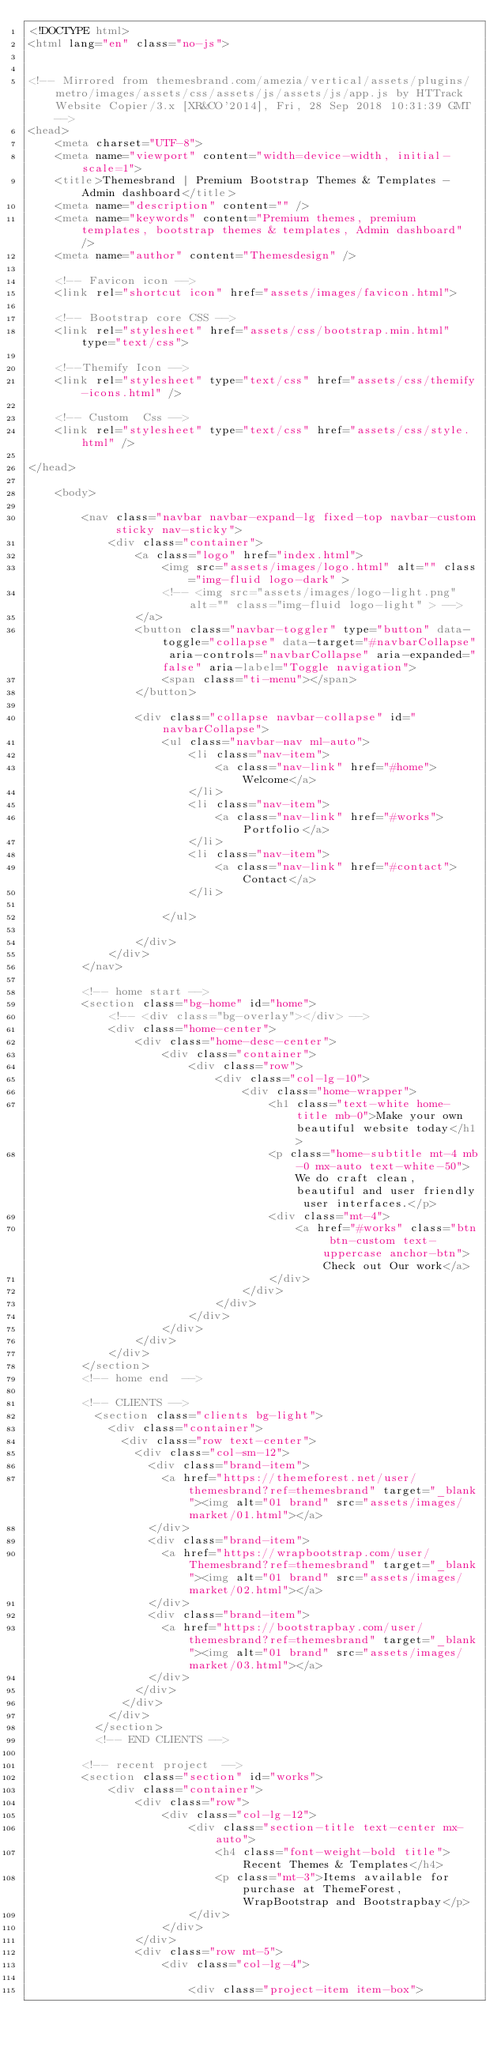Convert code to text. <code><loc_0><loc_0><loc_500><loc_500><_HTML_><!DOCTYPE html>
<html lang="en" class="no-js">


<!-- Mirrored from themesbrand.com/amezia/vertical/assets/plugins/metro/images/assets/css/assets/js/assets/js/app.js by HTTrack Website Copier/3.x [XR&CO'2014], Fri, 28 Sep 2018 10:31:39 GMT -->
<head>
    <meta charset="UTF-8">
    <meta name="viewport" content="width=device-width, initial-scale=1">
    <title>Themesbrand | Premium Bootstrap Themes & Templates - Admin dashboard</title>
    <meta name="description" content="" />
    <meta name="keywords" content="Premium themes, premium templates, bootstrap themes & templates, Admin dashboard" />
    <meta name="author" content="Themesdesign" />

    <!-- Favicon icon -->
    <link rel="shortcut icon" href="assets/images/favicon.html">

    <!-- Bootstrap core CSS -->
    <link rel="stylesheet" href="assets/css/bootstrap.min.html" type="text/css">

    <!--Themify Icon -->
    <link rel="stylesheet" type="text/css" href="assets/css/themify-icons.html" />

    <!-- Custom  Css -->
    <link rel="stylesheet" type="text/css" href="assets/css/style.html" />

</head>

    <body>

        <nav class="navbar navbar-expand-lg fixed-top navbar-custom sticky nav-sticky">
            <div class="container">
                <a class="logo" href="index.html">
                    <img src="assets/images/logo.html" alt="" class="img-fluid logo-dark" >
                    <!-- <img src="assets/images/logo-light.png" alt="" class="img-fluid logo-light" > -->
                </a>
                <button class="navbar-toggler" type="button" data-toggle="collapse" data-target="#navbarCollapse" aria-controls="navbarCollapse" aria-expanded="false" aria-label="Toggle navigation">
                    <span class="ti-menu"></span>
                </button>

                <div class="collapse navbar-collapse" id="navbarCollapse">
                    <ul class="navbar-nav ml-auto">
                        <li class="nav-item">
                            <a class="nav-link" href="#home">Welcome</a>
                        </li>
                        <li class="nav-item">
                            <a class="nav-link" href="#works">Portfolio</a>
                        </li>
                        <li class="nav-item">
                            <a class="nav-link" href="#contact">Contact</a>
                        </li>

                    </ul>

                </div>
            </div>
        </nav>

        <!-- home start -->
        <section class="bg-home" id="home">
            <!-- <div class="bg-overlay"></div> -->
            <div class="home-center">
                <div class="home-desc-center">
                    <div class="container">
                        <div class="row">
                            <div class="col-lg-10">
                                <div class="home-wrapper">
                                    <h1 class="text-white home-title mb-0">Make your own beautiful website today</h1>
                                    <p class="home-subtitle mt-4 mb-0 mx-auto text-white-50">We do craft clean, beautiful and user friendly user interfaces.</p>
                                    <div class="mt-4">
                                        <a href="#works" class="btn btn-custom text-uppercase anchor-btn">Check out Our work</a>
                                    </div>
                                </div>
                            </div>
                        </div>
                    </div>
                </div>
            </div>
        </section>
        <!-- home end  -->

        <!-- CLIENTS -->
          <section class="clients bg-light">
            <div class="container">
              <div class="row text-center">
                <div class="col-sm-12">
                  <div class="brand-item">
                    <a href="https://themeforest.net/user/themesbrand?ref=themesbrand" target="_blank"><img alt="01 brand" src="assets/images/market/01.html"></a>
                  </div>
                  <div class="brand-item">
                    <a href="https://wrapbootstrap.com/user/Themesbrand?ref=themesbrand" target="_blank"><img alt="01 brand" src="assets/images/market/02.html"></a>
                  </div>
                  <div class="brand-item">
                    <a href="https://bootstrapbay.com/user/themesbrand?ref=themesbrand" target="_blank"><img alt="01 brand" src="assets/images/market/03.html"></a>
                  </div>
                </div>
              </div>
            </div>
          </section>
          <!-- END CLIENTS -->

        <!-- recent project  -->
        <section class="section" id="works">
            <div class="container">
                <div class="row">
                    <div class="col-lg-12">
                        <div class="section-title text-center mx-auto">
                            <h4 class="font-weight-bold title">Recent Themes & Templates</h4>
                            <p class="mt-3">Items available for purchase at ThemeForest, WrapBootstrap and Bootstrapbay</p>
                        </div>
                    </div>
                </div>
                <div class="row mt-5">
                    <div class="col-lg-4">

                        <div class="project-item item-box"></code> 